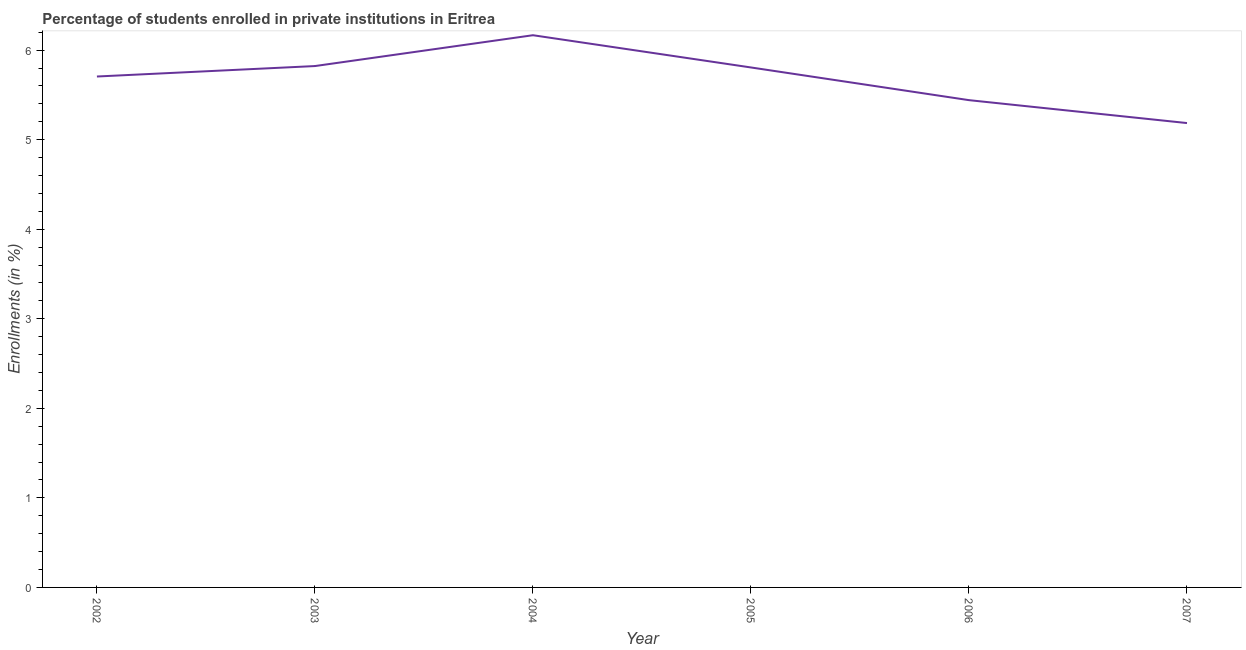What is the enrollments in private institutions in 2005?
Provide a short and direct response. 5.81. Across all years, what is the maximum enrollments in private institutions?
Keep it short and to the point. 6.17. Across all years, what is the minimum enrollments in private institutions?
Give a very brief answer. 5.19. In which year was the enrollments in private institutions maximum?
Provide a short and direct response. 2004. What is the sum of the enrollments in private institutions?
Give a very brief answer. 34.13. What is the difference between the enrollments in private institutions in 2002 and 2004?
Give a very brief answer. -0.46. What is the average enrollments in private institutions per year?
Provide a succinct answer. 5.69. What is the median enrollments in private institutions?
Offer a terse response. 5.76. In how many years, is the enrollments in private institutions greater than 5.6 %?
Keep it short and to the point. 4. Do a majority of the years between 2005 and 2002 (inclusive) have enrollments in private institutions greater than 5.8 %?
Your answer should be very brief. Yes. What is the ratio of the enrollments in private institutions in 2003 to that in 2005?
Provide a short and direct response. 1. Is the enrollments in private institutions in 2002 less than that in 2006?
Make the answer very short. No. What is the difference between the highest and the second highest enrollments in private institutions?
Keep it short and to the point. 0.34. What is the difference between the highest and the lowest enrollments in private institutions?
Provide a succinct answer. 0.98. In how many years, is the enrollments in private institutions greater than the average enrollments in private institutions taken over all years?
Offer a very short reply. 4. Does the enrollments in private institutions monotonically increase over the years?
Offer a very short reply. No. How many years are there in the graph?
Provide a succinct answer. 6. What is the difference between two consecutive major ticks on the Y-axis?
Offer a very short reply. 1. Does the graph contain any zero values?
Give a very brief answer. No. What is the title of the graph?
Provide a succinct answer. Percentage of students enrolled in private institutions in Eritrea. What is the label or title of the Y-axis?
Your answer should be very brief. Enrollments (in %). What is the Enrollments (in %) in 2002?
Offer a very short reply. 5.71. What is the Enrollments (in %) in 2003?
Make the answer very short. 5.82. What is the Enrollments (in %) of 2004?
Your response must be concise. 6.17. What is the Enrollments (in %) in 2005?
Make the answer very short. 5.81. What is the Enrollments (in %) in 2006?
Provide a succinct answer. 5.44. What is the Enrollments (in %) of 2007?
Provide a short and direct response. 5.19. What is the difference between the Enrollments (in %) in 2002 and 2003?
Your response must be concise. -0.12. What is the difference between the Enrollments (in %) in 2002 and 2004?
Your answer should be compact. -0.46. What is the difference between the Enrollments (in %) in 2002 and 2005?
Make the answer very short. -0.1. What is the difference between the Enrollments (in %) in 2002 and 2006?
Offer a very short reply. 0.26. What is the difference between the Enrollments (in %) in 2002 and 2007?
Give a very brief answer. 0.52. What is the difference between the Enrollments (in %) in 2003 and 2004?
Make the answer very short. -0.34. What is the difference between the Enrollments (in %) in 2003 and 2005?
Your answer should be very brief. 0.02. What is the difference between the Enrollments (in %) in 2003 and 2006?
Offer a very short reply. 0.38. What is the difference between the Enrollments (in %) in 2003 and 2007?
Give a very brief answer. 0.64. What is the difference between the Enrollments (in %) in 2004 and 2005?
Offer a very short reply. 0.36. What is the difference between the Enrollments (in %) in 2004 and 2006?
Offer a terse response. 0.73. What is the difference between the Enrollments (in %) in 2004 and 2007?
Offer a very short reply. 0.98. What is the difference between the Enrollments (in %) in 2005 and 2006?
Keep it short and to the point. 0.37. What is the difference between the Enrollments (in %) in 2005 and 2007?
Your answer should be compact. 0.62. What is the difference between the Enrollments (in %) in 2006 and 2007?
Make the answer very short. 0.26. What is the ratio of the Enrollments (in %) in 2002 to that in 2003?
Your response must be concise. 0.98. What is the ratio of the Enrollments (in %) in 2002 to that in 2004?
Offer a very short reply. 0.93. What is the ratio of the Enrollments (in %) in 2002 to that in 2006?
Your response must be concise. 1.05. What is the ratio of the Enrollments (in %) in 2002 to that in 2007?
Keep it short and to the point. 1.1. What is the ratio of the Enrollments (in %) in 2003 to that in 2004?
Offer a very short reply. 0.94. What is the ratio of the Enrollments (in %) in 2003 to that in 2005?
Your response must be concise. 1. What is the ratio of the Enrollments (in %) in 2003 to that in 2006?
Offer a terse response. 1.07. What is the ratio of the Enrollments (in %) in 2003 to that in 2007?
Provide a succinct answer. 1.12. What is the ratio of the Enrollments (in %) in 2004 to that in 2005?
Your answer should be very brief. 1.06. What is the ratio of the Enrollments (in %) in 2004 to that in 2006?
Your response must be concise. 1.13. What is the ratio of the Enrollments (in %) in 2004 to that in 2007?
Your answer should be compact. 1.19. What is the ratio of the Enrollments (in %) in 2005 to that in 2006?
Keep it short and to the point. 1.07. What is the ratio of the Enrollments (in %) in 2005 to that in 2007?
Provide a short and direct response. 1.12. What is the ratio of the Enrollments (in %) in 2006 to that in 2007?
Make the answer very short. 1.05. 